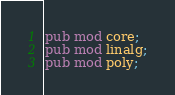Convert code to text. <code><loc_0><loc_0><loc_500><loc_500><_Rust_>pub mod core;
pub mod linalg;
pub mod poly;
</code> 